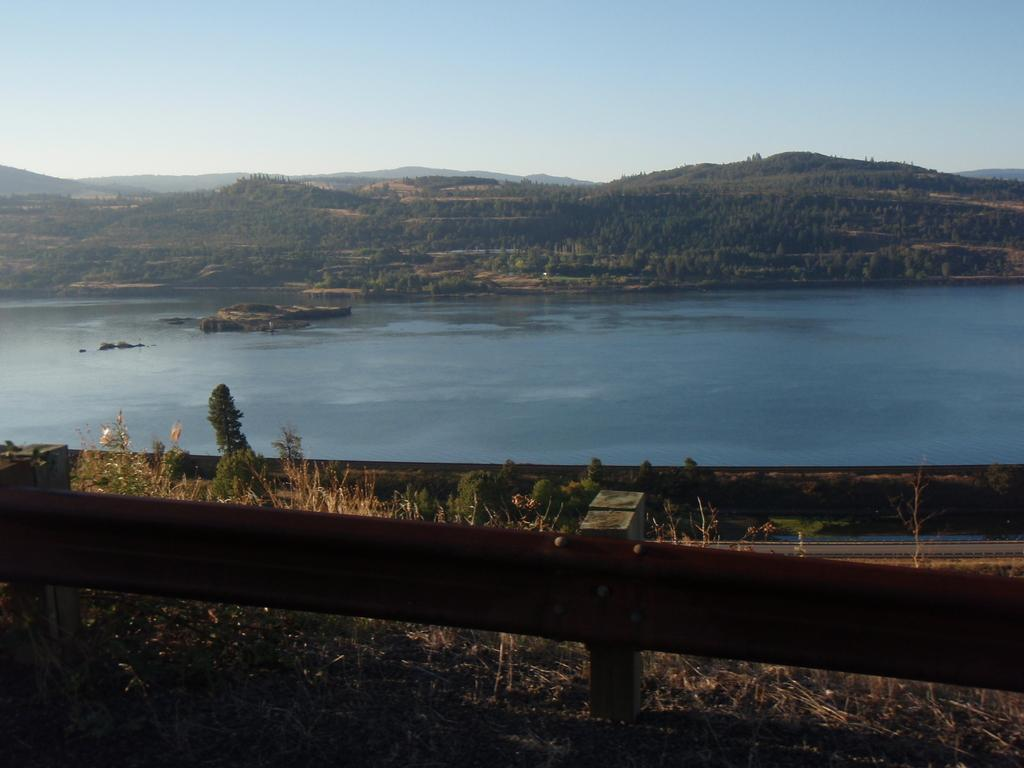What type of landscape feature is present on the hill in the image? There are trees on a hill in the image. What natural element can be seen in the image besides the trees? There is water visible in the image. What type of vegetation is present in the image besides the trees on the hill? There are plants in the image. What type of barrier is present in the image? There is a fence in the image. What is the condition of the sky in the image? The sky is cloudy in the image. What type of tub can be seen in the image? There is no tub present in the image. What type of drum is visible in the image? There is no drum present in the image. 